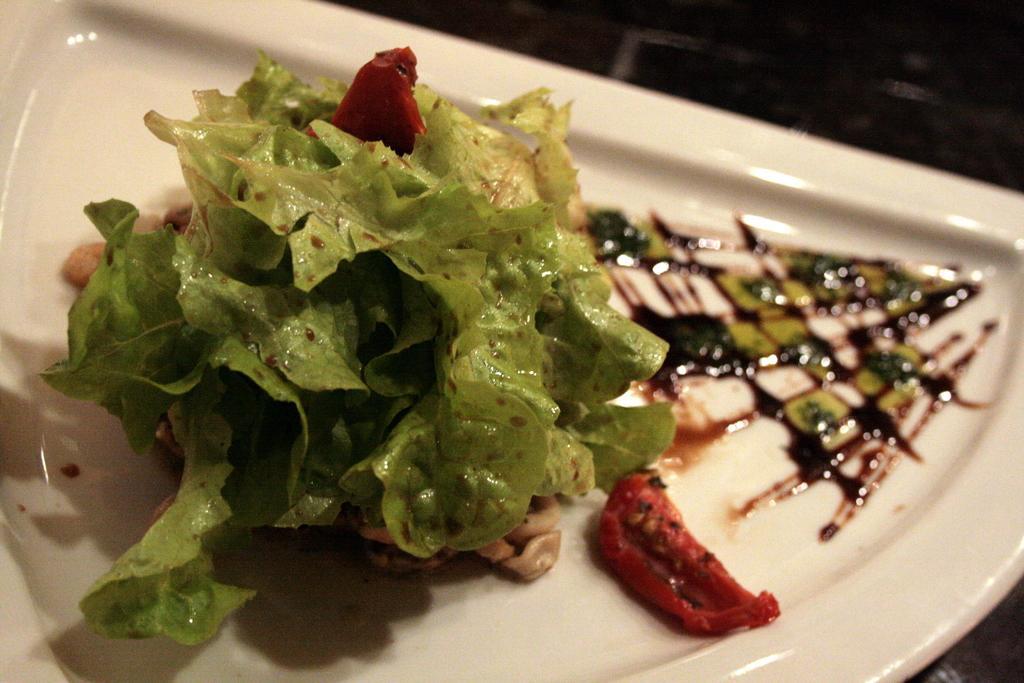Could you give a brief overview of what you see in this image? In this image there is a plate, in that place there is a food item. 